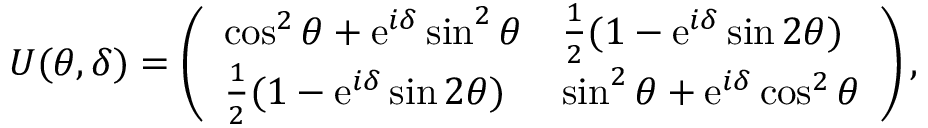Convert formula to latex. <formula><loc_0><loc_0><loc_500><loc_500>U ( \theta , \delta ) = \left ( \begin{array} { l l } { \cos ^ { 2 } { \theta } + e ^ { i \delta } \sin ^ { 2 } { \theta } } & { \frac { 1 } { 2 } ( 1 - e ^ { i \delta } \sin { 2 \theta } ) } \\ { \frac { 1 } { 2 } ( 1 - e ^ { i \delta } \sin { 2 \theta } ) } & { \sin ^ { 2 } { \theta } + e ^ { i \delta } \cos ^ { 2 } { \theta } } \end{array} \right ) ,</formula> 